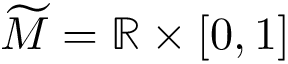Convert formula to latex. <formula><loc_0><loc_0><loc_500><loc_500>\widetilde { M } = \mathbb { R } \times [ 0 , 1 ]</formula> 